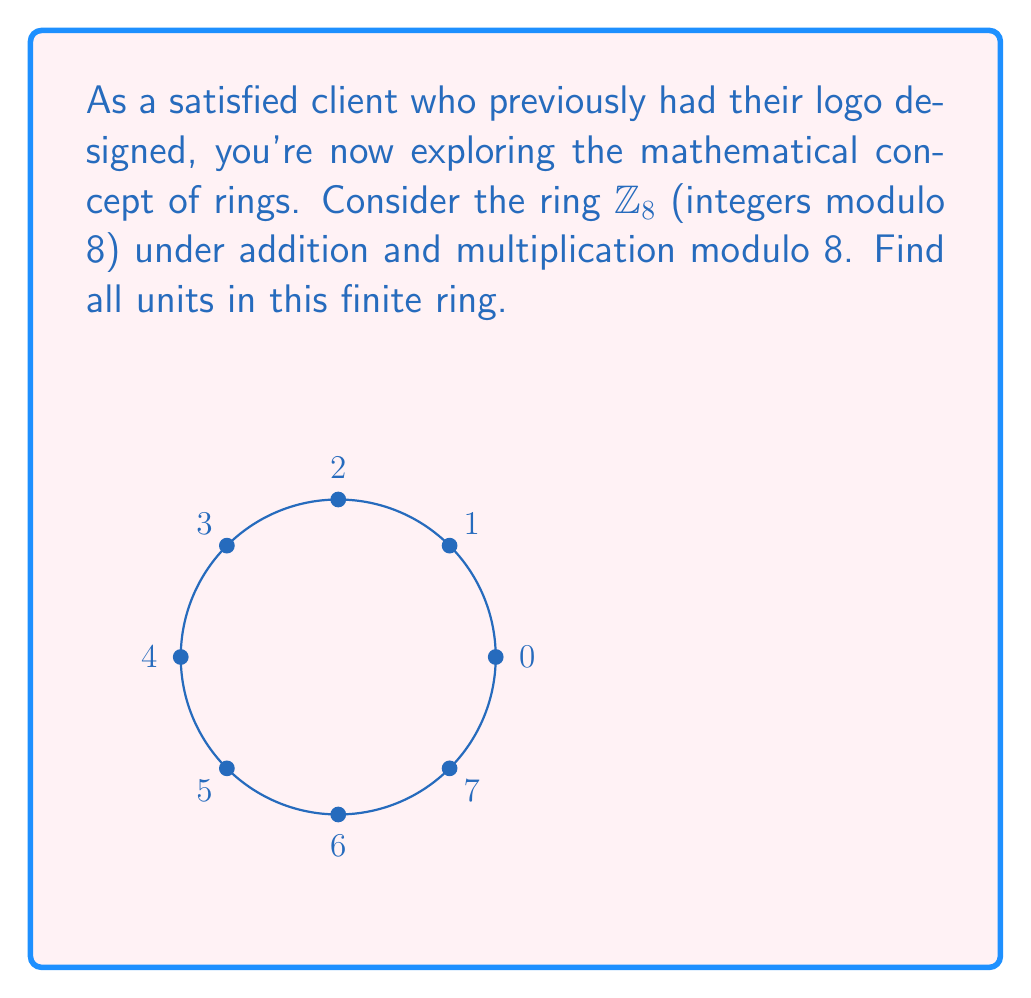Show me your answer to this math problem. To find all units in the ring $\mathbb{Z}_8$, we need to follow these steps:

1) Recall that a unit in a ring is an element that has a multiplicative inverse.

2) In $\mathbb{Z}_8$, we need to find all elements $a$ such that there exists a $b$ where $a \cdot b \equiv 1 \pmod{8}$.

3) Let's check each element:

   For $1$: $1 \cdot 1 \equiv 1 \pmod{8}$, so 1 is a unit.
   
   For $2$: No integer $b$ satisfies $2b \equiv 1 \pmod{8}$, so 2 is not a unit.
   
   For $3$: $3 \cdot 3 \equiv 1 \pmod{8}$, so 3 is a unit.
   
   For $4$: No integer $b$ satisfies $4b \equiv 1 \pmod{8}$, so 4 is not a unit.
   
   For $5$: $5 \cdot 5 \equiv 1 \pmod{8}$, so 5 is a unit.
   
   For $6$: No integer $b$ satisfies $6b \equiv 1 \pmod{8}$, so 6 is not a unit.
   
   For $7$: $7 \cdot 7 \equiv 1 \pmod{8}$, so 7 is a unit.

4) Therefore, the units in $\mathbb{Z}_8$ are 1, 3, 5, and 7.
Answer: $\{1, 3, 5, 7\}$ 